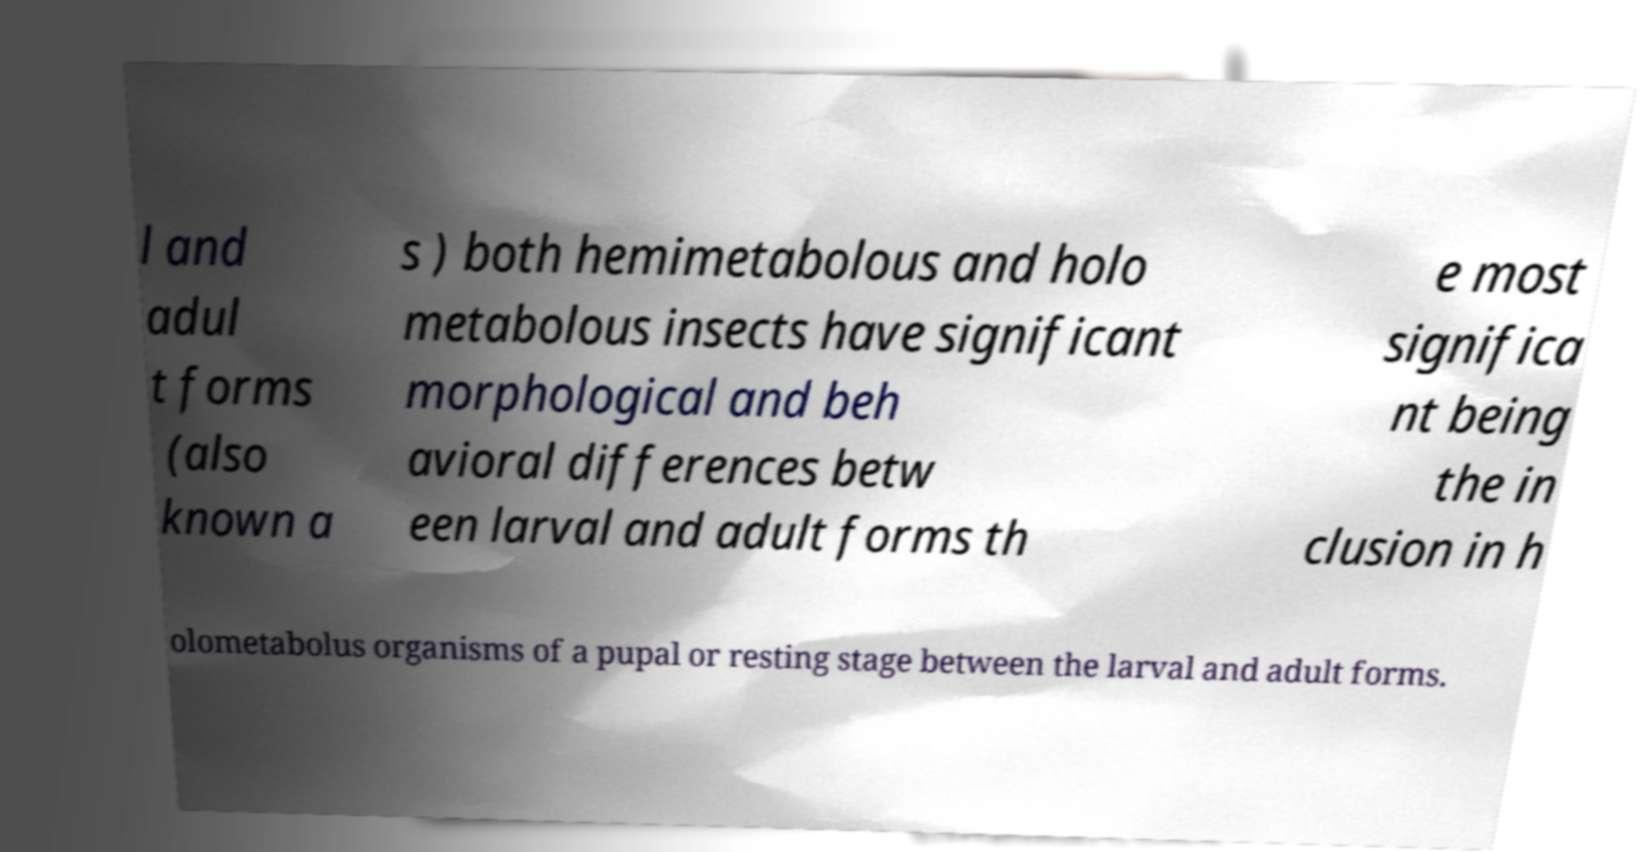Please read and relay the text visible in this image. What does it say? l and adul t forms (also known a s ) both hemimetabolous and holo metabolous insects have significant morphological and beh avioral differences betw een larval and adult forms th e most significa nt being the in clusion in h olometabolus organisms of a pupal or resting stage between the larval and adult forms. 